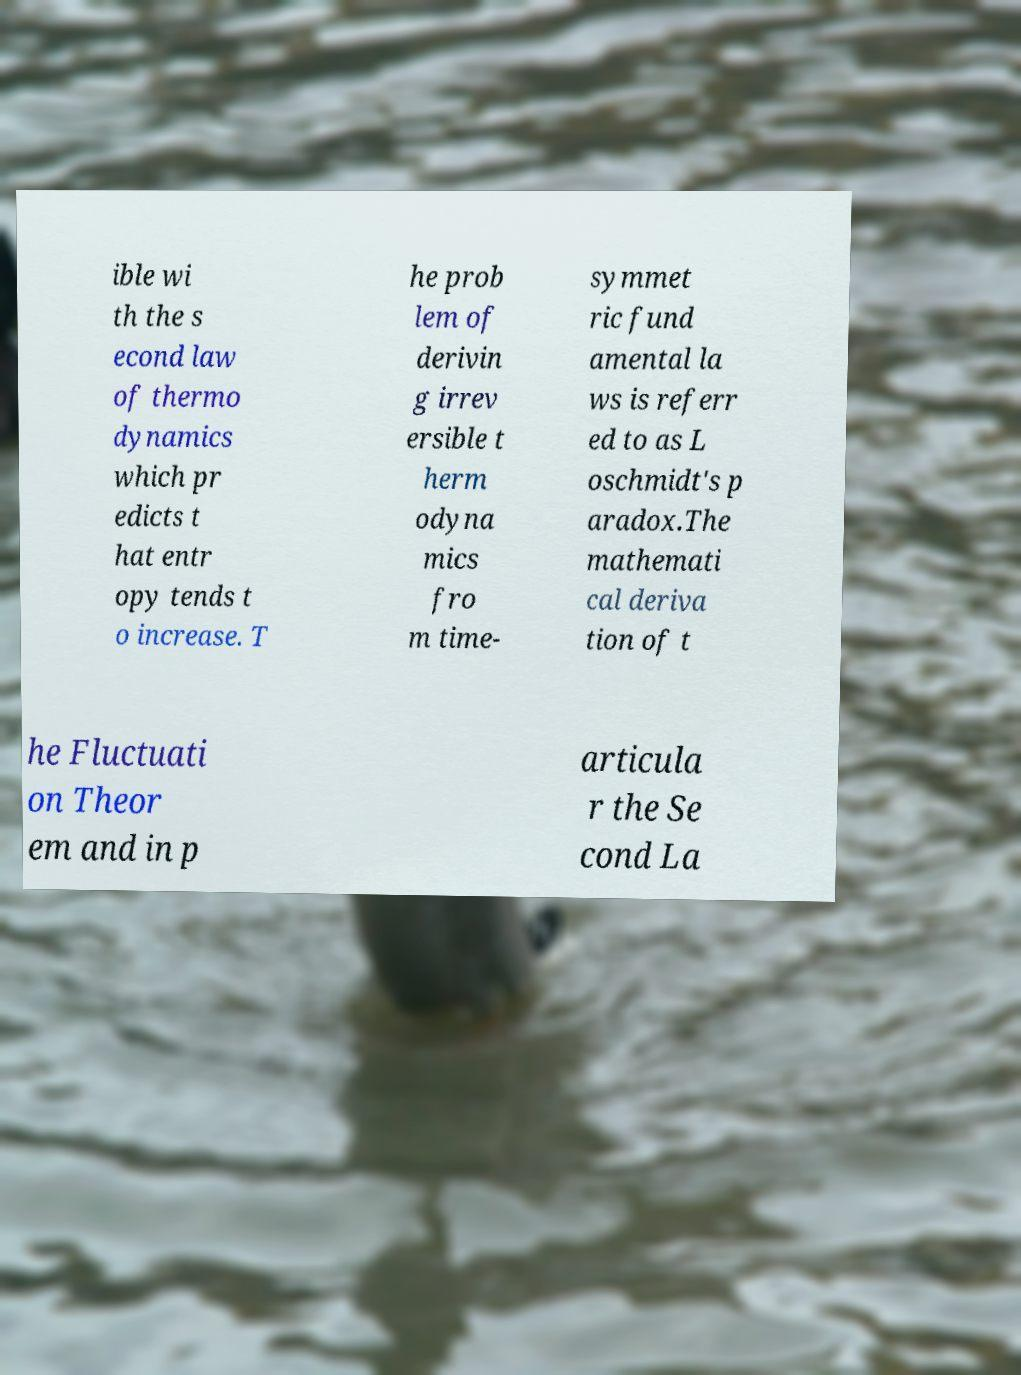For documentation purposes, I need the text within this image transcribed. Could you provide that? ible wi th the s econd law of thermo dynamics which pr edicts t hat entr opy tends t o increase. T he prob lem of derivin g irrev ersible t herm odyna mics fro m time- symmet ric fund amental la ws is referr ed to as L oschmidt's p aradox.The mathemati cal deriva tion of t he Fluctuati on Theor em and in p articula r the Se cond La 